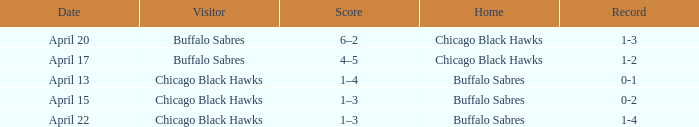When has a Record of 1-3? April 20. 